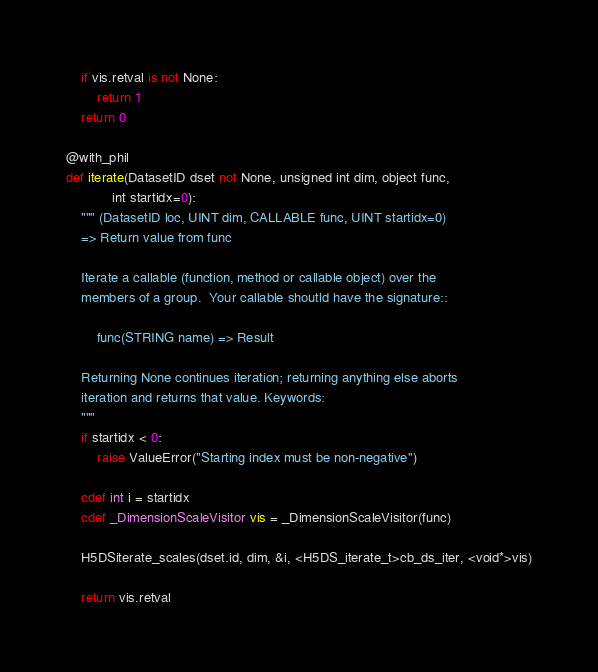Convert code to text. <code><loc_0><loc_0><loc_500><loc_500><_Cython_>    if vis.retval is not None:
        return 1
    return 0

@with_phil
def iterate(DatasetID dset not None, unsigned int dim, object func,
            int startidx=0):
    """ (DatasetID loc, UINT dim, CALLABLE func, UINT startidx=0)
    => Return value from func

    Iterate a callable (function, method or callable object) over the
    members of a group.  Your callable shoutld have the signature::

        func(STRING name) => Result

    Returning None continues iteration; returning anything else aborts
    iteration and returns that value. Keywords:
    """
    if startidx < 0:
        raise ValueError("Starting index must be non-negative")

    cdef int i = startidx
    cdef _DimensionScaleVisitor vis = _DimensionScaleVisitor(func)

    H5DSiterate_scales(dset.id, dim, &i, <H5DS_iterate_t>cb_ds_iter, <void*>vis)

    return vis.retval
</code> 